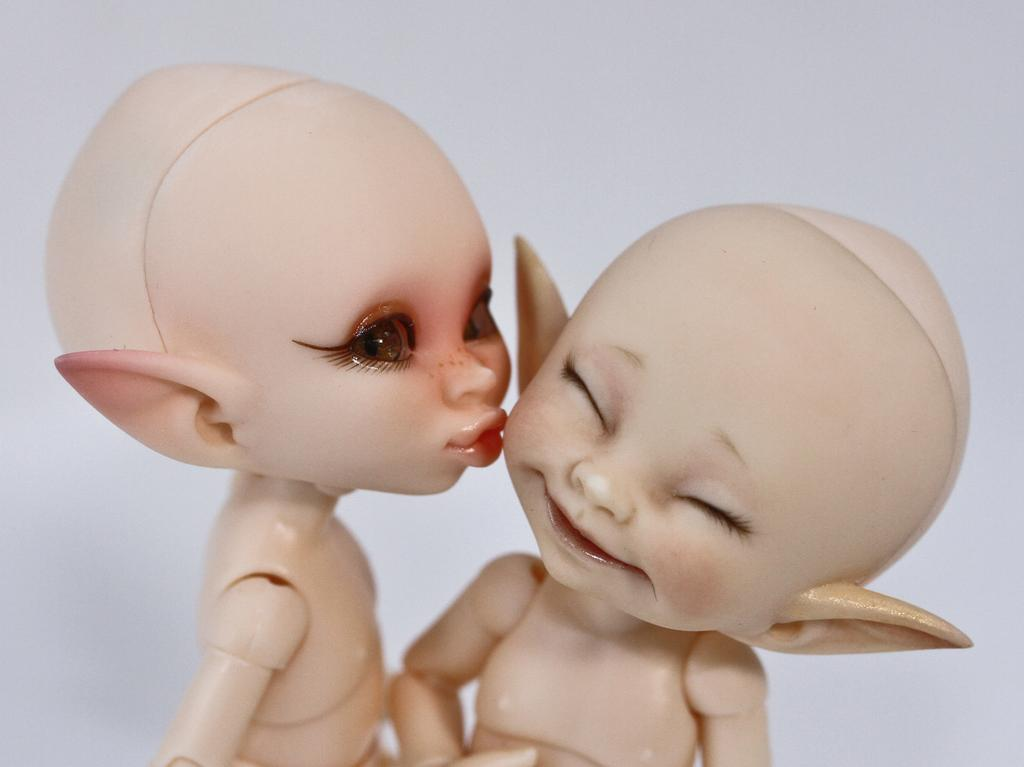How many toys are visible in the image? There are two toys in the image. What can be seen in the background of the image? The background of the image features a plane. What type of stone is being used to hear the toys in the image? There is no stone or hearing involved in the image; it simply features two toys and a plane in the background. 